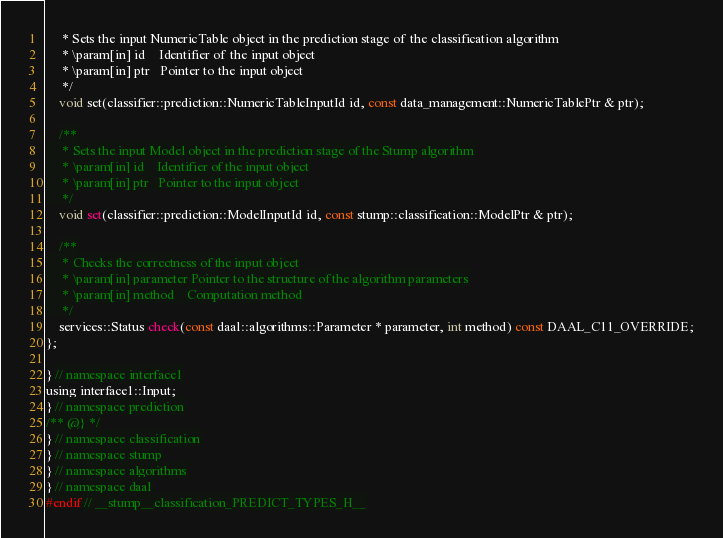Convert code to text. <code><loc_0><loc_0><loc_500><loc_500><_C_>     * Sets the input NumericTable object in the prediction stage of the classification algorithm
     * \param[in] id    Identifier of the input object
     * \param[in] ptr   Pointer to the input object
     */
    void set(classifier::prediction::NumericTableInputId id, const data_management::NumericTablePtr & ptr);

    /**
     * Sets the input Model object in the prediction stage of the Stump algorithm
     * \param[in] id    Identifier of the input object
     * \param[in] ptr   Pointer to the input object
     */
    void set(classifier::prediction::ModelInputId id, const stump::classification::ModelPtr & ptr);

    /**
     * Checks the correctness of the input object
     * \param[in] parameter Pointer to the structure of the algorithm parameters
     * \param[in] method    Computation method
     */
    services::Status check(const daal::algorithms::Parameter * parameter, int method) const DAAL_C11_OVERRIDE;
};

} // namespace interface1
using interface1::Input;
} // namespace prediction
/** @} */
} // namespace classification
} // namespace stump
} // namespace algorithms
} // namespace daal
#endif // __stump__classification_PREDICT_TYPES_H__
</code> 